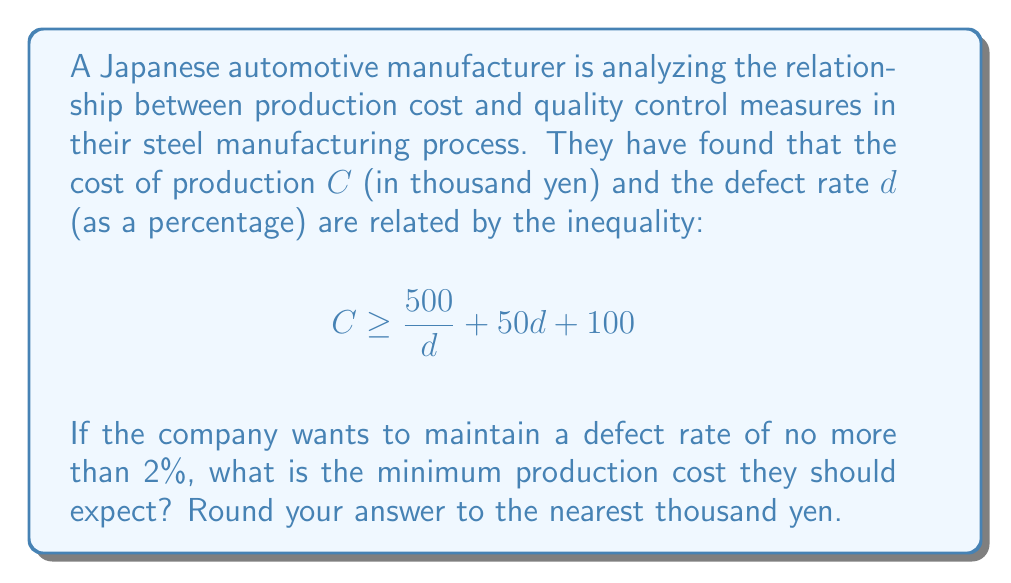Teach me how to tackle this problem. To solve this problem, we need to follow these steps:

1) We're given the inequality:
   $$ C \geq \frac{500}{d} + 50d + 100 $$

2) We want to find the minimum cost when the defect rate is at most 2%. Since the inequality uses $\geq$, the minimum cost will occur when the equality holds:
   $$ C = \frac{500}{d} + 50d + 100 $$

3) We're told that the defect rate should be no more than 2%, so we'll use $d = 2$ (as a percentage):
   $$ C = \frac{500}{2} + 50(2) + 100 $$

4) Let's calculate each term:
   - $\frac{500}{2} = 250$
   - $50(2) = 100$
   - The last term is already 100

5) Now we can sum these:
   $$ C = 250 + 100 + 100 = 450 $$

6) Remember that $C$ is in thousand yen, so this result means 450,000 yen.

7) The question asks to round to the nearest thousand yen, but our answer is already in thousands, so no further rounding is needed.
Answer: The minimum production cost the company should expect is 450,000 yen. 